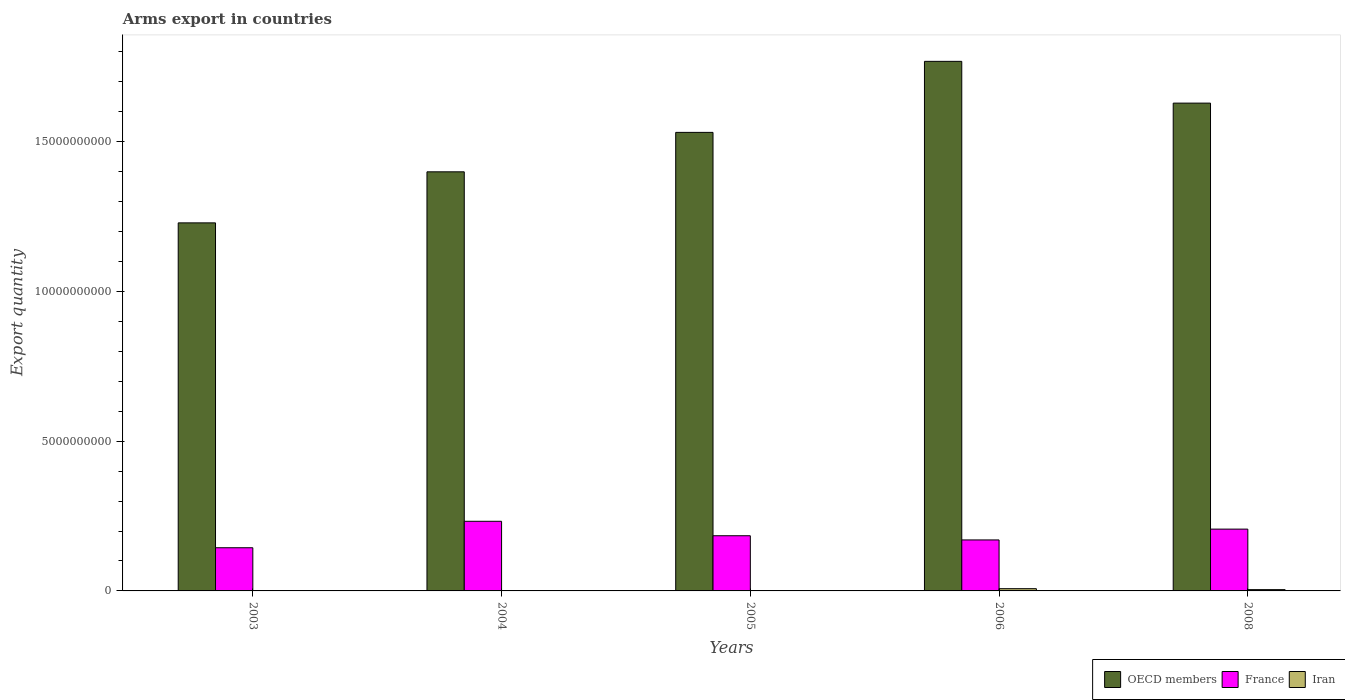Are the number of bars per tick equal to the number of legend labels?
Offer a terse response. Yes. Are the number of bars on each tick of the X-axis equal?
Provide a short and direct response. Yes. How many bars are there on the 1st tick from the right?
Give a very brief answer. 3. What is the label of the 3rd group of bars from the left?
Your answer should be compact. 2005. In how many cases, is the number of bars for a given year not equal to the number of legend labels?
Keep it short and to the point. 0. What is the total arms export in France in 2004?
Provide a succinct answer. 2.32e+09. Across all years, what is the maximum total arms export in OECD members?
Provide a short and direct response. 1.77e+1. Across all years, what is the minimum total arms export in OECD members?
Ensure brevity in your answer.  1.23e+1. In which year was the total arms export in OECD members maximum?
Your answer should be very brief. 2006. In which year was the total arms export in France minimum?
Offer a terse response. 2003. What is the total total arms export in France in the graph?
Give a very brief answer. 9.37e+09. What is the difference between the total arms export in OECD members in 2004 and that in 2006?
Your answer should be very brief. -3.69e+09. What is the difference between the total arms export in Iran in 2008 and the total arms export in OECD members in 2006?
Provide a short and direct response. -1.76e+1. What is the average total arms export in OECD members per year?
Keep it short and to the point. 1.51e+1. In the year 2008, what is the difference between the total arms export in France and total arms export in OECD members?
Provide a short and direct response. -1.42e+1. In how many years, is the total arms export in OECD members greater than 1000000000?
Give a very brief answer. 5. What is the ratio of the total arms export in Iran in 2006 to that in 2008?
Provide a short and direct response. 1.74. Is the total arms export in France in 2003 less than that in 2004?
Your response must be concise. Yes. Is the difference between the total arms export in France in 2003 and 2005 greater than the difference between the total arms export in OECD members in 2003 and 2005?
Make the answer very short. Yes. What is the difference between the highest and the second highest total arms export in OECD members?
Provide a short and direct response. 1.39e+09. What is the difference between the highest and the lowest total arms export in France?
Your answer should be very brief. 8.83e+08. In how many years, is the total arms export in OECD members greater than the average total arms export in OECD members taken over all years?
Give a very brief answer. 3. Is the sum of the total arms export in France in 2004 and 2005 greater than the maximum total arms export in OECD members across all years?
Provide a short and direct response. No. What does the 2nd bar from the right in 2005 represents?
Offer a terse response. France. Are all the bars in the graph horizontal?
Make the answer very short. No. Are the values on the major ticks of Y-axis written in scientific E-notation?
Give a very brief answer. No. Does the graph contain any zero values?
Offer a very short reply. No. Does the graph contain grids?
Offer a terse response. No. How are the legend labels stacked?
Provide a succinct answer. Horizontal. What is the title of the graph?
Your answer should be very brief. Arms export in countries. What is the label or title of the X-axis?
Provide a succinct answer. Years. What is the label or title of the Y-axis?
Provide a succinct answer. Export quantity. What is the Export quantity of OECD members in 2003?
Provide a short and direct response. 1.23e+1. What is the Export quantity in France in 2003?
Give a very brief answer. 1.44e+09. What is the Export quantity of Iran in 2003?
Ensure brevity in your answer.  9.00e+06. What is the Export quantity of OECD members in 2004?
Make the answer very short. 1.40e+1. What is the Export quantity in France in 2004?
Make the answer very short. 2.32e+09. What is the Export quantity of Iran in 2004?
Provide a short and direct response. 1.00e+06. What is the Export quantity of OECD members in 2005?
Give a very brief answer. 1.53e+1. What is the Export quantity in France in 2005?
Provide a short and direct response. 1.84e+09. What is the Export quantity of OECD members in 2006?
Your answer should be compact. 1.77e+1. What is the Export quantity in France in 2006?
Provide a succinct answer. 1.70e+09. What is the Export quantity of Iran in 2006?
Your answer should be very brief. 7.50e+07. What is the Export quantity in OECD members in 2008?
Offer a terse response. 1.63e+1. What is the Export quantity in France in 2008?
Your answer should be very brief. 2.06e+09. What is the Export quantity in Iran in 2008?
Provide a short and direct response. 4.30e+07. Across all years, what is the maximum Export quantity of OECD members?
Your answer should be very brief. 1.77e+1. Across all years, what is the maximum Export quantity in France?
Offer a very short reply. 2.32e+09. Across all years, what is the maximum Export quantity in Iran?
Make the answer very short. 7.50e+07. Across all years, what is the minimum Export quantity of OECD members?
Make the answer very short. 1.23e+1. Across all years, what is the minimum Export quantity of France?
Your response must be concise. 1.44e+09. What is the total Export quantity of OECD members in the graph?
Your response must be concise. 7.55e+1. What is the total Export quantity of France in the graph?
Your response must be concise. 9.37e+09. What is the total Export quantity of Iran in the graph?
Make the answer very short. 1.30e+08. What is the difference between the Export quantity in OECD members in 2003 and that in 2004?
Your response must be concise. -1.70e+09. What is the difference between the Export quantity of France in 2003 and that in 2004?
Provide a succinct answer. -8.83e+08. What is the difference between the Export quantity of OECD members in 2003 and that in 2005?
Ensure brevity in your answer.  -3.02e+09. What is the difference between the Export quantity in France in 2003 and that in 2005?
Offer a terse response. -4.01e+08. What is the difference between the Export quantity of Iran in 2003 and that in 2005?
Your answer should be very brief. 7.00e+06. What is the difference between the Export quantity in OECD members in 2003 and that in 2006?
Ensure brevity in your answer.  -5.39e+09. What is the difference between the Export quantity in France in 2003 and that in 2006?
Ensure brevity in your answer.  -2.61e+08. What is the difference between the Export quantity in Iran in 2003 and that in 2006?
Give a very brief answer. -6.60e+07. What is the difference between the Export quantity of OECD members in 2003 and that in 2008?
Provide a succinct answer. -4.00e+09. What is the difference between the Export quantity of France in 2003 and that in 2008?
Provide a succinct answer. -6.22e+08. What is the difference between the Export quantity of Iran in 2003 and that in 2008?
Ensure brevity in your answer.  -3.40e+07. What is the difference between the Export quantity of OECD members in 2004 and that in 2005?
Your response must be concise. -1.32e+09. What is the difference between the Export quantity in France in 2004 and that in 2005?
Provide a succinct answer. 4.82e+08. What is the difference between the Export quantity of Iran in 2004 and that in 2005?
Keep it short and to the point. -1.00e+06. What is the difference between the Export quantity of OECD members in 2004 and that in 2006?
Your response must be concise. -3.69e+09. What is the difference between the Export quantity of France in 2004 and that in 2006?
Keep it short and to the point. 6.22e+08. What is the difference between the Export quantity of Iran in 2004 and that in 2006?
Offer a very short reply. -7.40e+07. What is the difference between the Export quantity of OECD members in 2004 and that in 2008?
Your response must be concise. -2.29e+09. What is the difference between the Export quantity in France in 2004 and that in 2008?
Keep it short and to the point. 2.61e+08. What is the difference between the Export quantity of Iran in 2004 and that in 2008?
Offer a very short reply. -4.20e+07. What is the difference between the Export quantity in OECD members in 2005 and that in 2006?
Provide a succinct answer. -2.37e+09. What is the difference between the Export quantity of France in 2005 and that in 2006?
Offer a very short reply. 1.40e+08. What is the difference between the Export quantity in Iran in 2005 and that in 2006?
Offer a very short reply. -7.30e+07. What is the difference between the Export quantity in OECD members in 2005 and that in 2008?
Ensure brevity in your answer.  -9.77e+08. What is the difference between the Export quantity of France in 2005 and that in 2008?
Your answer should be compact. -2.21e+08. What is the difference between the Export quantity in Iran in 2005 and that in 2008?
Provide a short and direct response. -4.10e+07. What is the difference between the Export quantity of OECD members in 2006 and that in 2008?
Provide a short and direct response. 1.39e+09. What is the difference between the Export quantity of France in 2006 and that in 2008?
Your answer should be compact. -3.61e+08. What is the difference between the Export quantity of Iran in 2006 and that in 2008?
Make the answer very short. 3.20e+07. What is the difference between the Export quantity of OECD members in 2003 and the Export quantity of France in 2004?
Your response must be concise. 9.96e+09. What is the difference between the Export quantity of OECD members in 2003 and the Export quantity of Iran in 2004?
Provide a short and direct response. 1.23e+1. What is the difference between the Export quantity of France in 2003 and the Export quantity of Iran in 2004?
Your response must be concise. 1.44e+09. What is the difference between the Export quantity of OECD members in 2003 and the Export quantity of France in 2005?
Offer a terse response. 1.04e+1. What is the difference between the Export quantity of OECD members in 2003 and the Export quantity of Iran in 2005?
Keep it short and to the point. 1.23e+1. What is the difference between the Export quantity of France in 2003 and the Export quantity of Iran in 2005?
Provide a short and direct response. 1.44e+09. What is the difference between the Export quantity in OECD members in 2003 and the Export quantity in France in 2006?
Give a very brief answer. 1.06e+1. What is the difference between the Export quantity in OECD members in 2003 and the Export quantity in Iran in 2006?
Provide a short and direct response. 1.22e+1. What is the difference between the Export quantity of France in 2003 and the Export quantity of Iran in 2006?
Ensure brevity in your answer.  1.37e+09. What is the difference between the Export quantity in OECD members in 2003 and the Export quantity in France in 2008?
Your answer should be compact. 1.02e+1. What is the difference between the Export quantity of OECD members in 2003 and the Export quantity of Iran in 2008?
Keep it short and to the point. 1.22e+1. What is the difference between the Export quantity of France in 2003 and the Export quantity of Iran in 2008?
Provide a short and direct response. 1.40e+09. What is the difference between the Export quantity of OECD members in 2004 and the Export quantity of France in 2005?
Keep it short and to the point. 1.21e+1. What is the difference between the Export quantity in OECD members in 2004 and the Export quantity in Iran in 2005?
Ensure brevity in your answer.  1.40e+1. What is the difference between the Export quantity of France in 2004 and the Export quantity of Iran in 2005?
Ensure brevity in your answer.  2.32e+09. What is the difference between the Export quantity in OECD members in 2004 and the Export quantity in France in 2006?
Give a very brief answer. 1.23e+1. What is the difference between the Export quantity in OECD members in 2004 and the Export quantity in Iran in 2006?
Ensure brevity in your answer.  1.39e+1. What is the difference between the Export quantity of France in 2004 and the Export quantity of Iran in 2006?
Offer a terse response. 2.25e+09. What is the difference between the Export quantity of OECD members in 2004 and the Export quantity of France in 2008?
Ensure brevity in your answer.  1.19e+1. What is the difference between the Export quantity in OECD members in 2004 and the Export quantity in Iran in 2008?
Your answer should be compact. 1.39e+1. What is the difference between the Export quantity in France in 2004 and the Export quantity in Iran in 2008?
Keep it short and to the point. 2.28e+09. What is the difference between the Export quantity in OECD members in 2005 and the Export quantity in France in 2006?
Your answer should be compact. 1.36e+1. What is the difference between the Export quantity in OECD members in 2005 and the Export quantity in Iran in 2006?
Provide a succinct answer. 1.52e+1. What is the difference between the Export quantity in France in 2005 and the Export quantity in Iran in 2006?
Make the answer very short. 1.77e+09. What is the difference between the Export quantity of OECD members in 2005 and the Export quantity of France in 2008?
Ensure brevity in your answer.  1.32e+1. What is the difference between the Export quantity of OECD members in 2005 and the Export quantity of Iran in 2008?
Provide a short and direct response. 1.53e+1. What is the difference between the Export quantity in France in 2005 and the Export quantity in Iran in 2008?
Make the answer very short. 1.80e+09. What is the difference between the Export quantity in OECD members in 2006 and the Export quantity in France in 2008?
Offer a very short reply. 1.56e+1. What is the difference between the Export quantity in OECD members in 2006 and the Export quantity in Iran in 2008?
Give a very brief answer. 1.76e+1. What is the difference between the Export quantity of France in 2006 and the Export quantity of Iran in 2008?
Your answer should be very brief. 1.66e+09. What is the average Export quantity in OECD members per year?
Ensure brevity in your answer.  1.51e+1. What is the average Export quantity of France per year?
Ensure brevity in your answer.  1.87e+09. What is the average Export quantity of Iran per year?
Ensure brevity in your answer.  2.60e+07. In the year 2003, what is the difference between the Export quantity of OECD members and Export quantity of France?
Give a very brief answer. 1.08e+1. In the year 2003, what is the difference between the Export quantity of OECD members and Export quantity of Iran?
Provide a short and direct response. 1.23e+1. In the year 2003, what is the difference between the Export quantity of France and Export quantity of Iran?
Provide a succinct answer. 1.43e+09. In the year 2004, what is the difference between the Export quantity in OECD members and Export quantity in France?
Your answer should be compact. 1.17e+1. In the year 2004, what is the difference between the Export quantity of OECD members and Export quantity of Iran?
Make the answer very short. 1.40e+1. In the year 2004, what is the difference between the Export quantity in France and Export quantity in Iran?
Your answer should be compact. 2.32e+09. In the year 2005, what is the difference between the Export quantity of OECD members and Export quantity of France?
Offer a very short reply. 1.35e+1. In the year 2005, what is the difference between the Export quantity of OECD members and Export quantity of Iran?
Offer a very short reply. 1.53e+1. In the year 2005, what is the difference between the Export quantity of France and Export quantity of Iran?
Your answer should be compact. 1.84e+09. In the year 2006, what is the difference between the Export quantity of OECD members and Export quantity of France?
Keep it short and to the point. 1.60e+1. In the year 2006, what is the difference between the Export quantity in OECD members and Export quantity in Iran?
Offer a terse response. 1.76e+1. In the year 2006, what is the difference between the Export quantity in France and Export quantity in Iran?
Keep it short and to the point. 1.63e+09. In the year 2008, what is the difference between the Export quantity in OECD members and Export quantity in France?
Provide a succinct answer. 1.42e+1. In the year 2008, what is the difference between the Export quantity in OECD members and Export quantity in Iran?
Provide a short and direct response. 1.62e+1. In the year 2008, what is the difference between the Export quantity in France and Export quantity in Iran?
Your response must be concise. 2.02e+09. What is the ratio of the Export quantity of OECD members in 2003 to that in 2004?
Provide a short and direct response. 0.88. What is the ratio of the Export quantity in France in 2003 to that in 2004?
Provide a succinct answer. 0.62. What is the ratio of the Export quantity in Iran in 2003 to that in 2004?
Your response must be concise. 9. What is the ratio of the Export quantity in OECD members in 2003 to that in 2005?
Provide a short and direct response. 0.8. What is the ratio of the Export quantity in France in 2003 to that in 2005?
Your answer should be very brief. 0.78. What is the ratio of the Export quantity in Iran in 2003 to that in 2005?
Provide a short and direct response. 4.5. What is the ratio of the Export quantity in OECD members in 2003 to that in 2006?
Provide a short and direct response. 0.69. What is the ratio of the Export quantity of France in 2003 to that in 2006?
Your response must be concise. 0.85. What is the ratio of the Export quantity of Iran in 2003 to that in 2006?
Provide a short and direct response. 0.12. What is the ratio of the Export quantity of OECD members in 2003 to that in 2008?
Ensure brevity in your answer.  0.75. What is the ratio of the Export quantity of France in 2003 to that in 2008?
Give a very brief answer. 0.7. What is the ratio of the Export quantity of Iran in 2003 to that in 2008?
Offer a very short reply. 0.21. What is the ratio of the Export quantity in OECD members in 2004 to that in 2005?
Provide a succinct answer. 0.91. What is the ratio of the Export quantity in France in 2004 to that in 2005?
Ensure brevity in your answer.  1.26. What is the ratio of the Export quantity in OECD members in 2004 to that in 2006?
Your answer should be compact. 0.79. What is the ratio of the Export quantity of France in 2004 to that in 2006?
Your response must be concise. 1.37. What is the ratio of the Export quantity in Iran in 2004 to that in 2006?
Provide a short and direct response. 0.01. What is the ratio of the Export quantity in OECD members in 2004 to that in 2008?
Give a very brief answer. 0.86. What is the ratio of the Export quantity of France in 2004 to that in 2008?
Your answer should be compact. 1.13. What is the ratio of the Export quantity of Iran in 2004 to that in 2008?
Ensure brevity in your answer.  0.02. What is the ratio of the Export quantity of OECD members in 2005 to that in 2006?
Your response must be concise. 0.87. What is the ratio of the Export quantity in France in 2005 to that in 2006?
Offer a very short reply. 1.08. What is the ratio of the Export quantity of Iran in 2005 to that in 2006?
Provide a short and direct response. 0.03. What is the ratio of the Export quantity in OECD members in 2005 to that in 2008?
Provide a short and direct response. 0.94. What is the ratio of the Export quantity in France in 2005 to that in 2008?
Provide a succinct answer. 0.89. What is the ratio of the Export quantity of Iran in 2005 to that in 2008?
Provide a succinct answer. 0.05. What is the ratio of the Export quantity in OECD members in 2006 to that in 2008?
Offer a very short reply. 1.09. What is the ratio of the Export quantity in France in 2006 to that in 2008?
Make the answer very short. 0.82. What is the ratio of the Export quantity in Iran in 2006 to that in 2008?
Your answer should be very brief. 1.74. What is the difference between the highest and the second highest Export quantity of OECD members?
Provide a succinct answer. 1.39e+09. What is the difference between the highest and the second highest Export quantity of France?
Your response must be concise. 2.61e+08. What is the difference between the highest and the second highest Export quantity of Iran?
Your answer should be compact. 3.20e+07. What is the difference between the highest and the lowest Export quantity of OECD members?
Offer a terse response. 5.39e+09. What is the difference between the highest and the lowest Export quantity in France?
Provide a short and direct response. 8.83e+08. What is the difference between the highest and the lowest Export quantity of Iran?
Keep it short and to the point. 7.40e+07. 